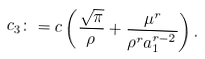<formula> <loc_0><loc_0><loc_500><loc_500>c _ { 3 } \colon = c \left ( \frac { \sqrt { \pi } } { \rho } + \frac { \mu ^ { r } } { \rho ^ { r } a _ { 1 } ^ { r - 2 } } \right ) .</formula> 